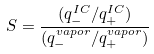Convert formula to latex. <formula><loc_0><loc_0><loc_500><loc_500>S = \frac { ( q _ { - } ^ { I C } / q _ { + } ^ { I C } ) } { ( q _ { - } ^ { v a p o r } / q _ { + } ^ { v a p o r } ) }</formula> 